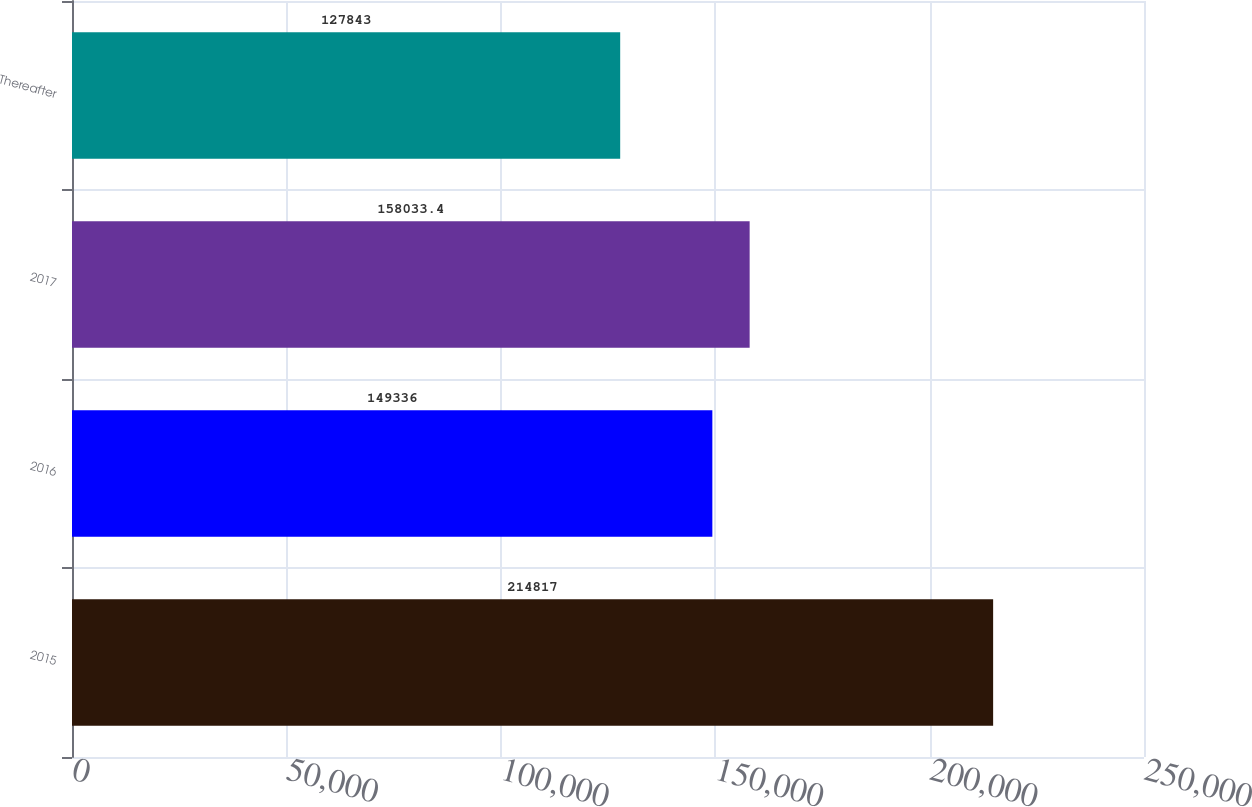Convert chart to OTSL. <chart><loc_0><loc_0><loc_500><loc_500><bar_chart><fcel>2015<fcel>2016<fcel>2017<fcel>Thereafter<nl><fcel>214817<fcel>149336<fcel>158033<fcel>127843<nl></chart> 